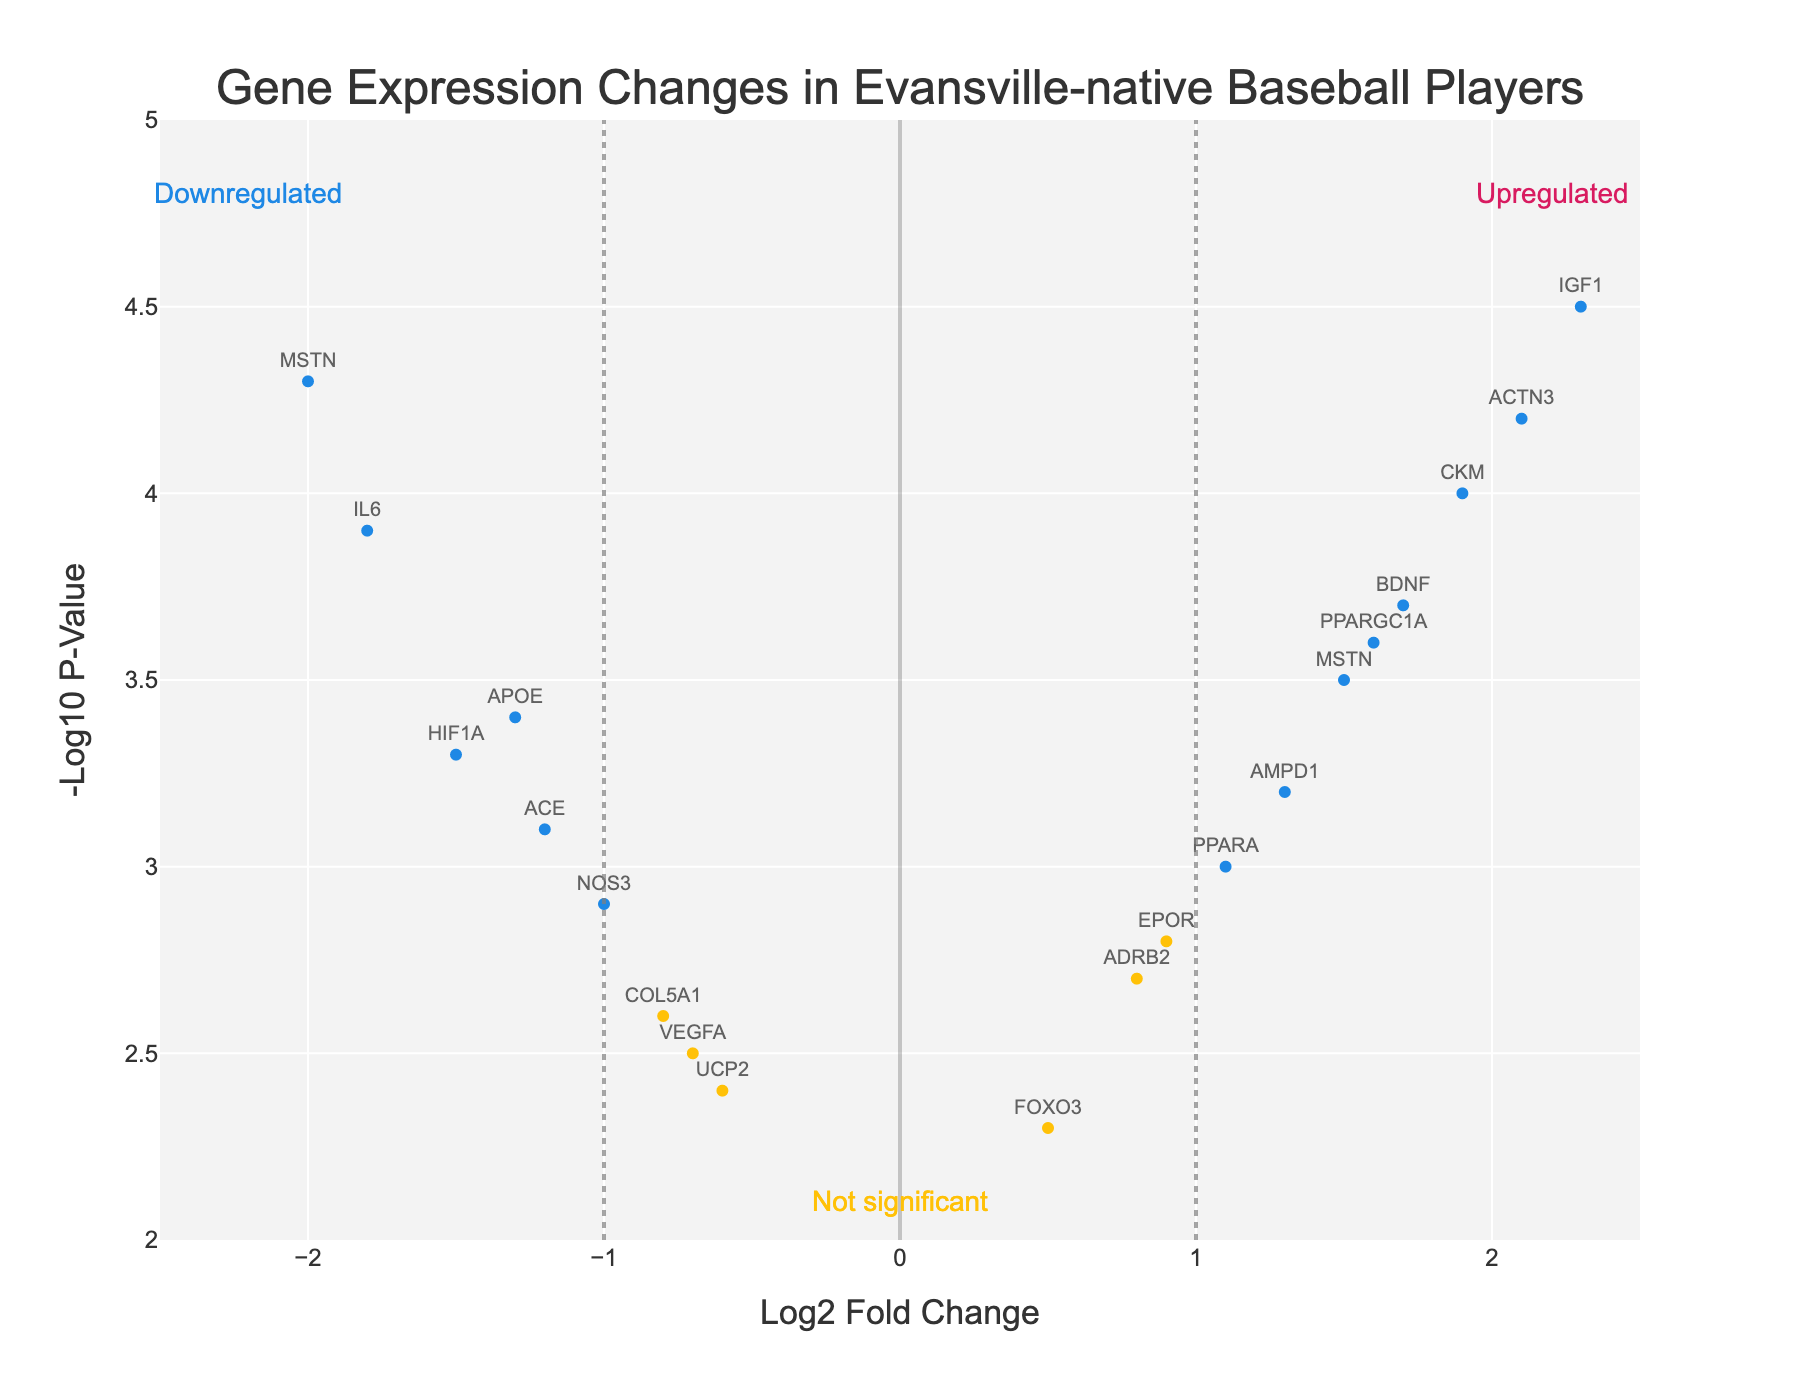What's the title of the plot? The title is displayed prominently at the top center of the plot.
Answer: Gene Expression Changes in Evansville-native Baseball Players What do the colors in the plot represent? The colors differentiate the significance categories: blue for downregulated genes, yellow for not significant genes, and pink for upregulated genes.
Answer: Downregulated, Not Significant, Upregulated How many genes are considered significantly upregulated in Evansville-native baseball players? Significantly upregulated genes are those with a Log2FoldChange ≥ 1 and a -Log10 P-Value ≥ 1.3. The pink points represent these genes. By examining the plot, we see four such genes (ACTN3, BDNF, IGF1, CKM).
Answer: 4 Which gene has the highest Log2FoldChange? The highest Log2FoldChange can be found by identifying the point farthest to the right on the x-axis. It is the gene IGF1 with a Log2FoldChange of 2.3.
Answer: IGF1 Which gene has the highest -Log10 P-Value? The highest -Log10 P-Value is represented by the point highest on the y-axis. It is the gene MSTN with a value of 4.3.
Answer: MSTN Are there any genes that are both downregulated and have a significant -Log10 P-Value? To find such genes, look for those with negative Log2FoldChange values less than -1 and a -Log10 P-Value greater than 1.3. MSTN and IL6 meet these criteria.
Answer: MSTN, IL6 What is the range of Log2FoldChange values displayed in the plot? The x-axis range can be determined by the labeled ticks, which show the points span from -2.5 to 2.5.
Answer: -2.5 to 2.5 Which gene has the lowest -Log10 P-Value and still considered not significant? The lowest -Log10 P-Value among not significant genes (yellow points) can be found near the bottom of the y-axis within the yellow points. It is UCP2 with a value of 2.4.
Answer: UCP2 Which gene has the closest value of Log2FoldChange to zero but is still considered significant? The gene closest to zero Log2FoldChange with a -Log10 P-Value above 1.3 is EPOR with a Log2FoldChange of 0.9.
Answer: EPOR 